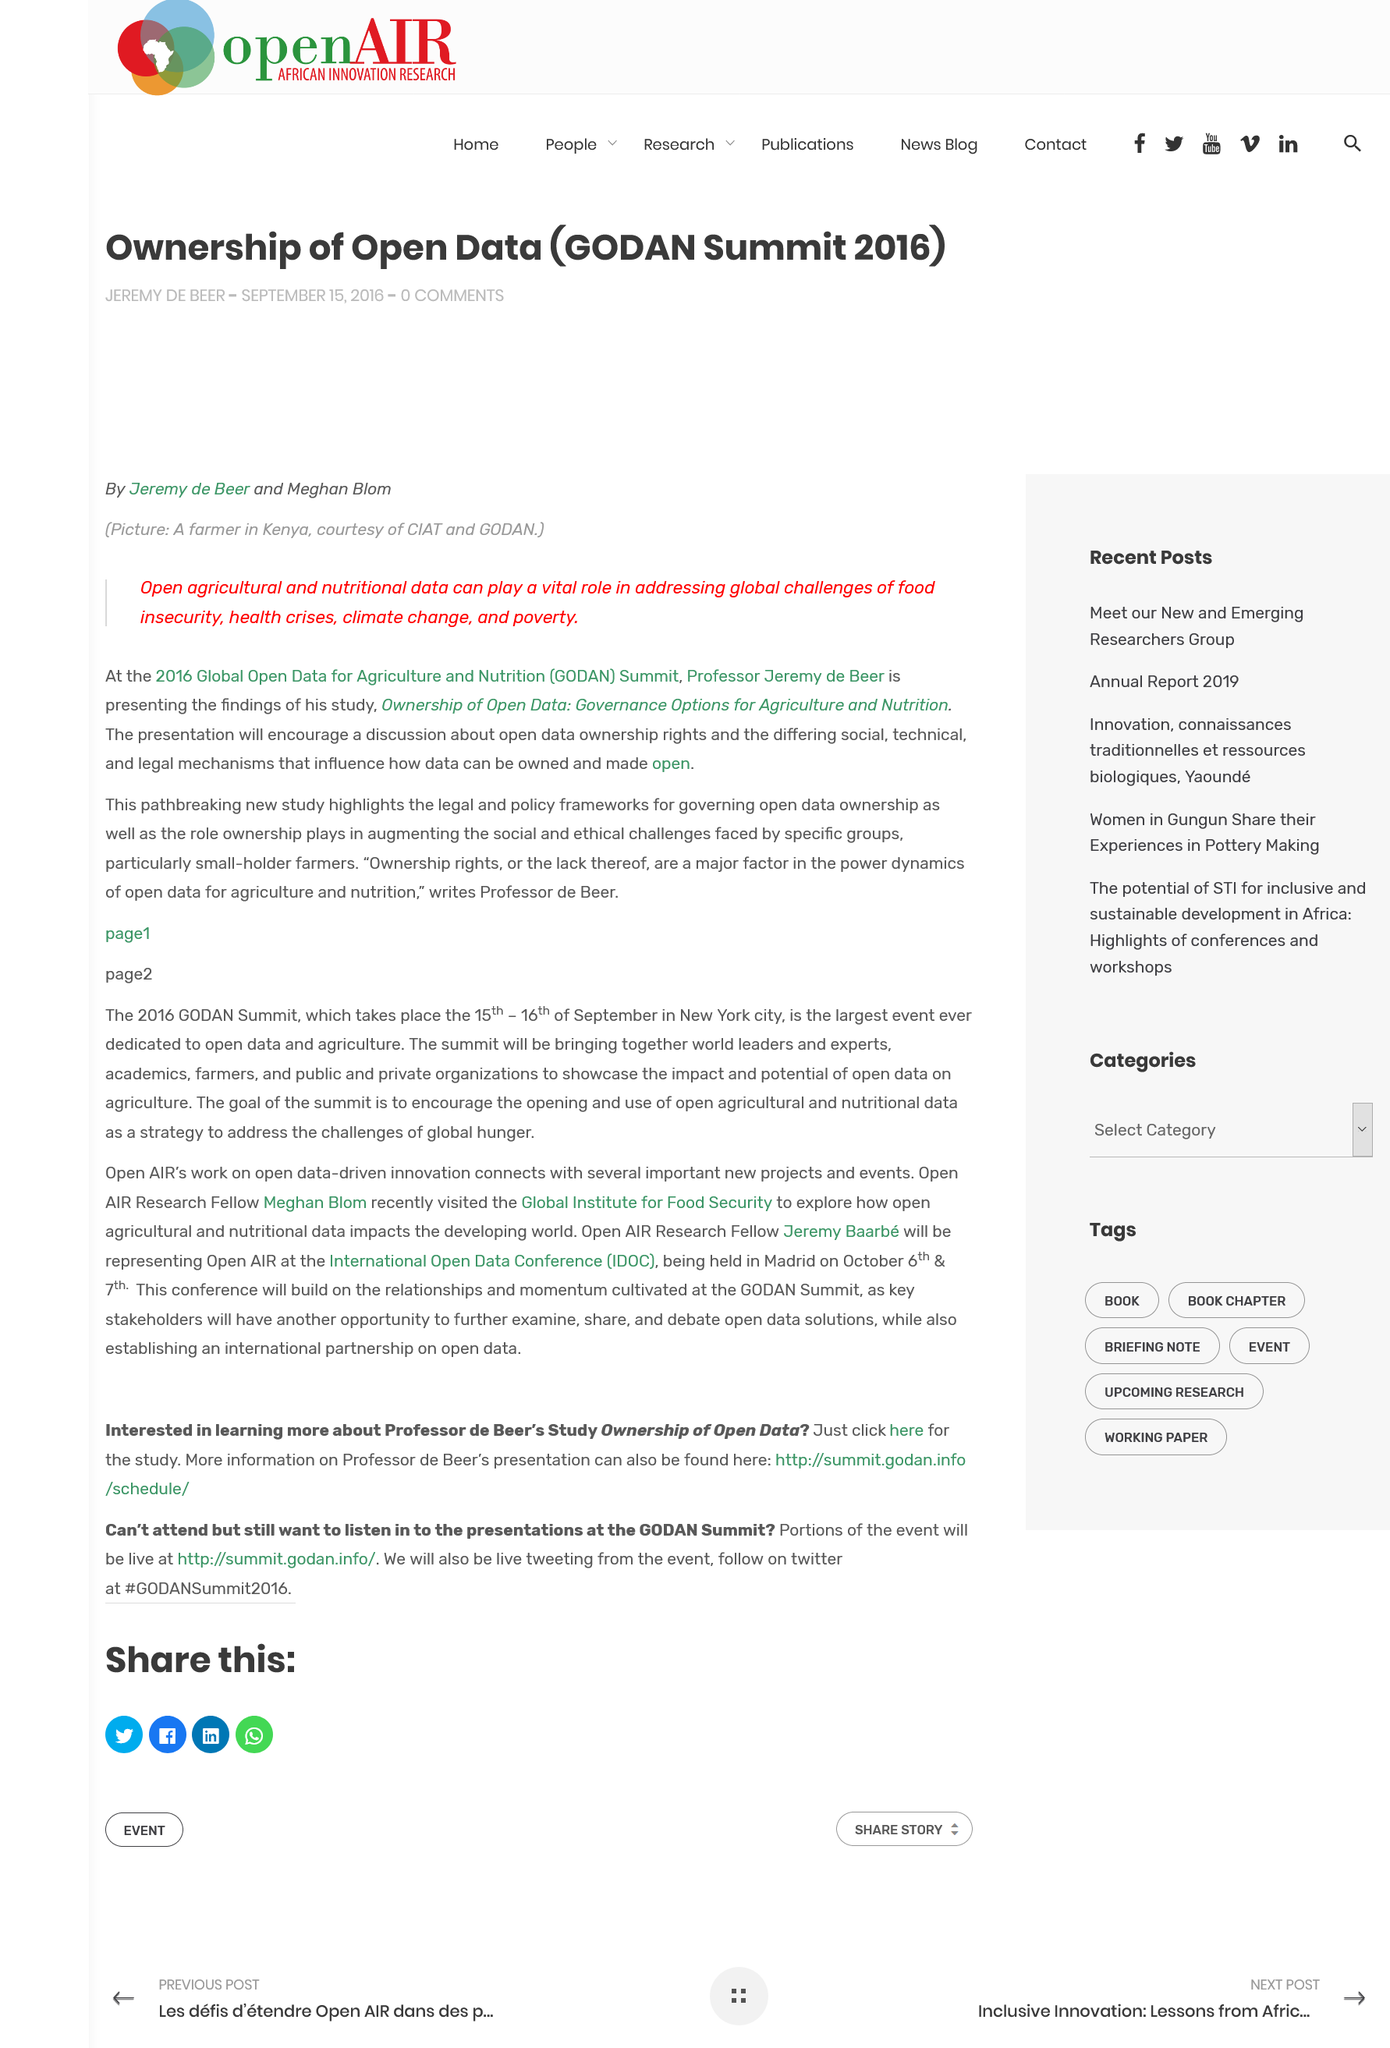Highlight a few significant elements in this photo. The presentation aims to encourage a discussion on the topic of open data ownership rights and the various social, technical, and legal mechanisms that impact the ability to own and make open data. The presenter of the study is Professor Jeremy de Beer. The GODAN Summit took place in 2016. 